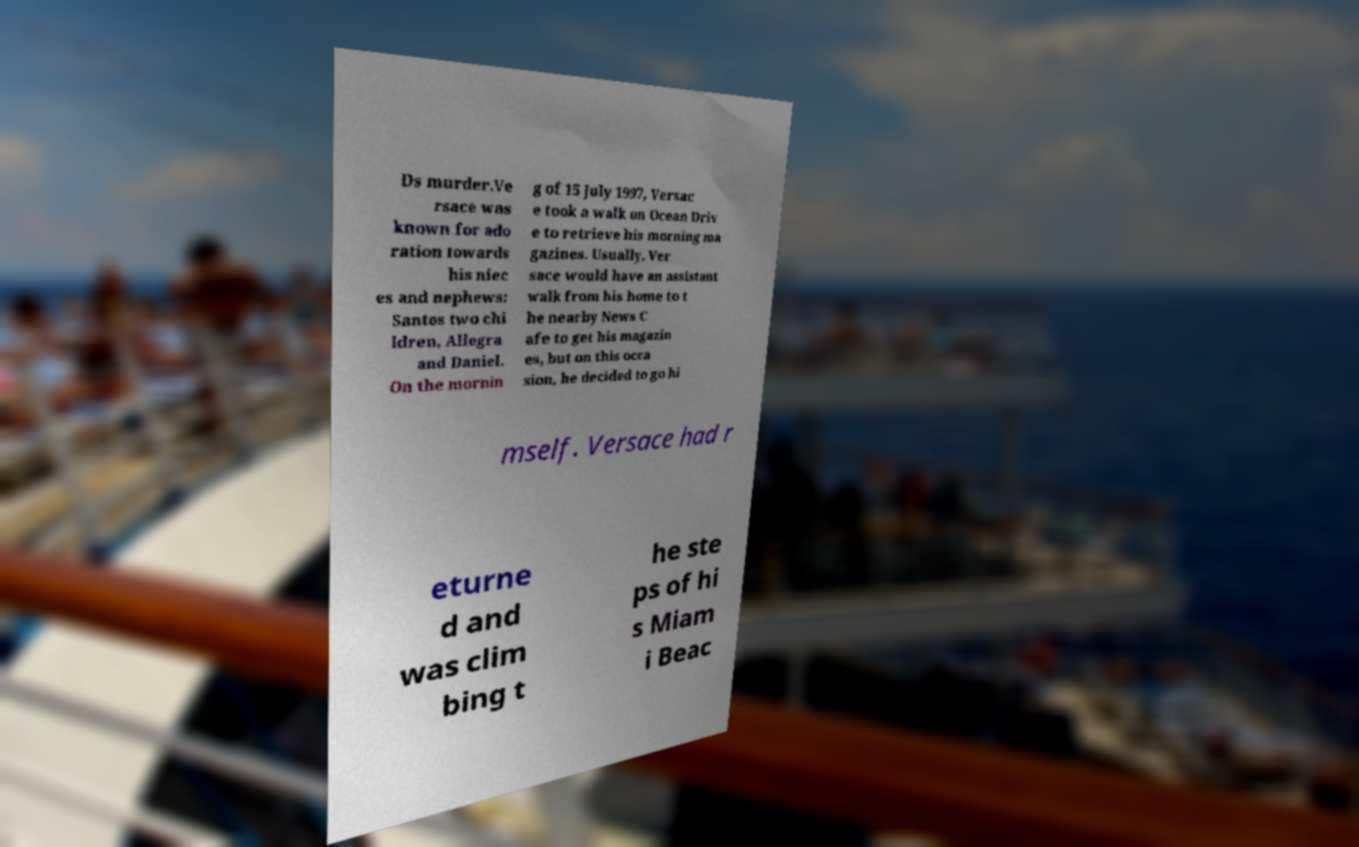I need the written content from this picture converted into text. Can you do that? Ds murder.Ve rsace was known for ado ration towards his niec es and nephews: Santos two chi ldren, Allegra and Daniel. On the mornin g of 15 July 1997, Versac e took a walk on Ocean Driv e to retrieve his morning ma gazines. Usually, Ver sace would have an assistant walk from his home to t he nearby News C afe to get his magazin es, but on this occa sion, he decided to go hi mself. Versace had r eturne d and was clim bing t he ste ps of hi s Miam i Beac 